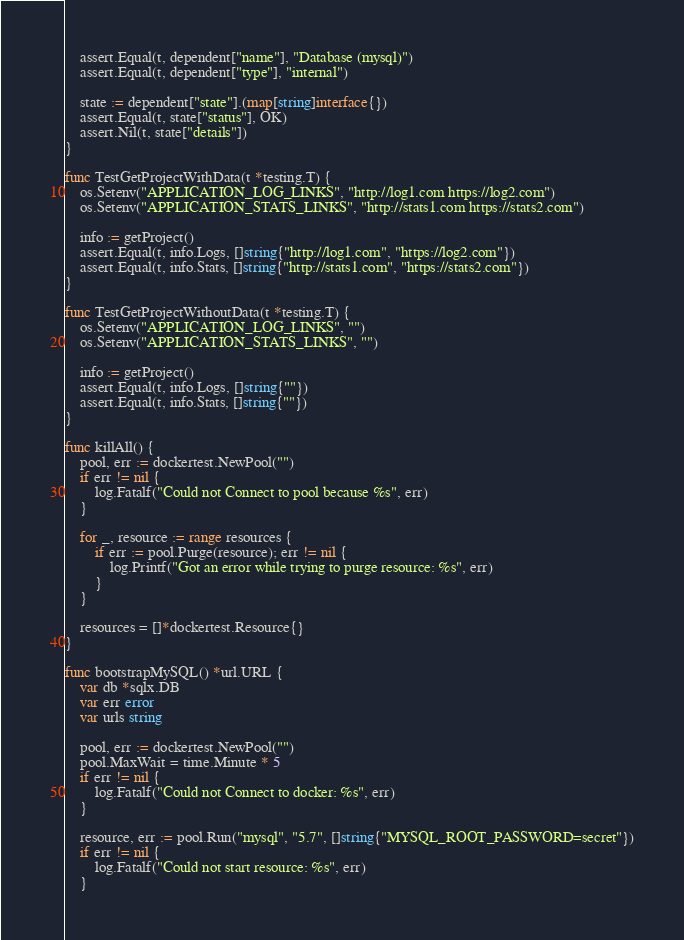<code> <loc_0><loc_0><loc_500><loc_500><_Go_>	assert.Equal(t, dependent["name"], "Database (mysql)")
	assert.Equal(t, dependent["type"], "internal")

	state := dependent["state"].(map[string]interface{})
	assert.Equal(t, state["status"], OK)
	assert.Nil(t, state["details"])
}

func TestGetProjectWithData(t *testing.T) {
	os.Setenv("APPLICATION_LOG_LINKS", "http://log1.com https://log2.com")
	os.Setenv("APPLICATION_STATS_LINKS", "http://stats1.com https://stats2.com")

	info := getProject()
	assert.Equal(t, info.Logs, []string{"http://log1.com", "https://log2.com"})
	assert.Equal(t, info.Stats, []string{"http://stats1.com", "https://stats2.com"})
}

func TestGetProjectWithoutData(t *testing.T) {
	os.Setenv("APPLICATION_LOG_LINKS", "")
	os.Setenv("APPLICATION_STATS_LINKS", "")

	info := getProject()
	assert.Equal(t, info.Logs, []string{""})
	assert.Equal(t, info.Stats, []string{""})
}

func killAll() {
	pool, err := dockertest.NewPool("")
	if err != nil {
		log.Fatalf("Could not Connect to pool because %s", err)
	}

	for _, resource := range resources {
		if err := pool.Purge(resource); err != nil {
			log.Printf("Got an error while trying to purge resource: %s", err)
		}
	}

	resources = []*dockertest.Resource{}
}

func bootstrapMySQL() *url.URL {
	var db *sqlx.DB
	var err error
	var urls string

	pool, err := dockertest.NewPool("")
	pool.MaxWait = time.Minute * 5
	if err != nil {
		log.Fatalf("Could not Connect to docker: %s", err)
	}

	resource, err := pool.Run("mysql", "5.7", []string{"MYSQL_ROOT_PASSWORD=secret"})
	if err != nil {
		log.Fatalf("Could not start resource: %s", err)
	}
</code> 